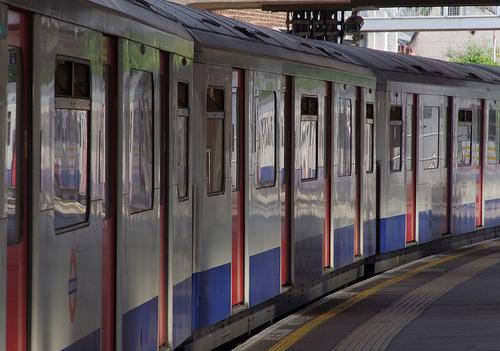What is on the train's doors and what colors are they? There's a logo on the train's doors with red and blue colors. What can be seen in the center of the image and how does it appear? The image shows a red, white, and blue train going around a curve, with a dark roof and blue stripes on its doors. What notable feature can you see regarding the train windows? The train windows are lowered, and there's a reflection in the train window glass. How many red doors can be seen on the train? Nine red doors are visible on the train. What type of train is present in the image, and how can it be distinguished? A red and blue passenger train is present, identifiable by its red doors, company logo, and blue stripes on the doors. Name an object found above the train in the picture and describe its color and position. A metal beam, which is silver and located above the train towards the right side, can be observed. What safety feature can be observed near the train in the image? A yellow safety boundary line is visible near the train for passenger safety. Describe the environment surrounding the train platform in the image. The environment includes a brick building behind the train, white bricks on the platform, a green tree in the background, and nearby houses with siding. Can you identify a specific architectural feature present in the background of the image? In the background, there is a brick building wall, which enhances the setting of the train platform. What kind of setting is this picture taken in? The photo is set at a train platform with a brick building in the background, a yellow safety line, and a green tree. 